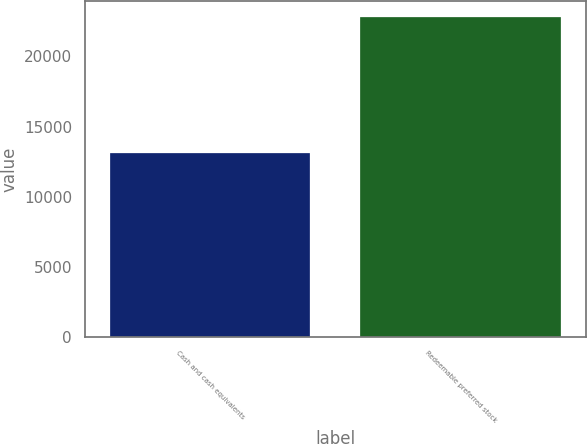Convert chart to OTSL. <chart><loc_0><loc_0><loc_500><loc_500><bar_chart><fcel>Cash and cash equivalents<fcel>Redeemable preferred stock<nl><fcel>13112<fcel>22794<nl></chart> 